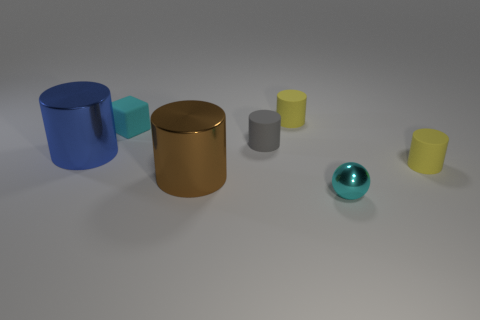Subtract all brown cylinders. How many cylinders are left? 4 Subtract all green cylinders. Subtract all gray spheres. How many cylinders are left? 5 Add 2 yellow things. How many objects exist? 9 Subtract all blocks. How many objects are left? 6 Add 3 large blue shiny objects. How many large blue shiny objects are left? 4 Add 1 tiny brown blocks. How many tiny brown blocks exist? 1 Subtract 0 gray cubes. How many objects are left? 7 Subtract all big blue metal cylinders. Subtract all small green shiny things. How many objects are left? 6 